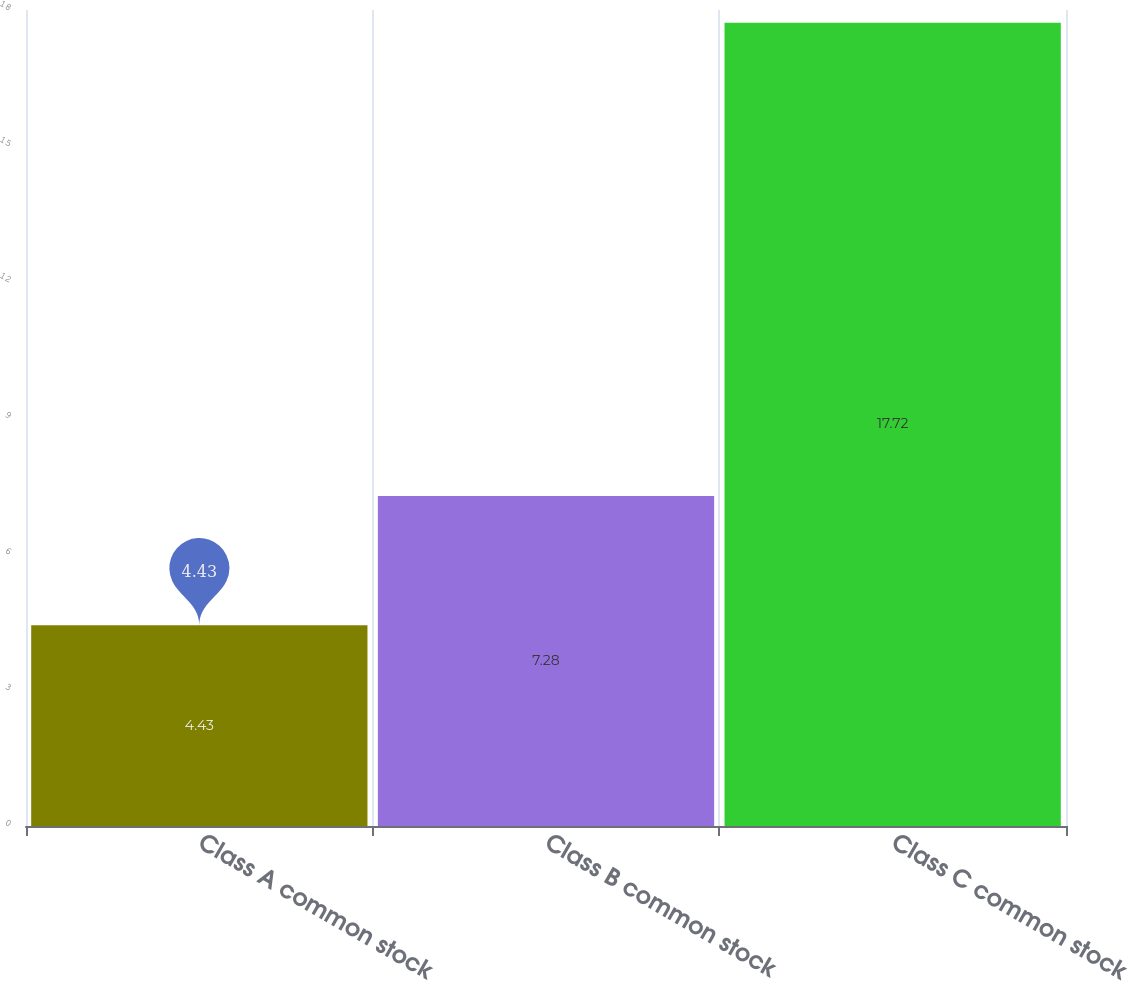<chart> <loc_0><loc_0><loc_500><loc_500><bar_chart><fcel>Class A common stock<fcel>Class B common stock<fcel>Class C common stock<nl><fcel>4.43<fcel>7.28<fcel>17.72<nl></chart> 